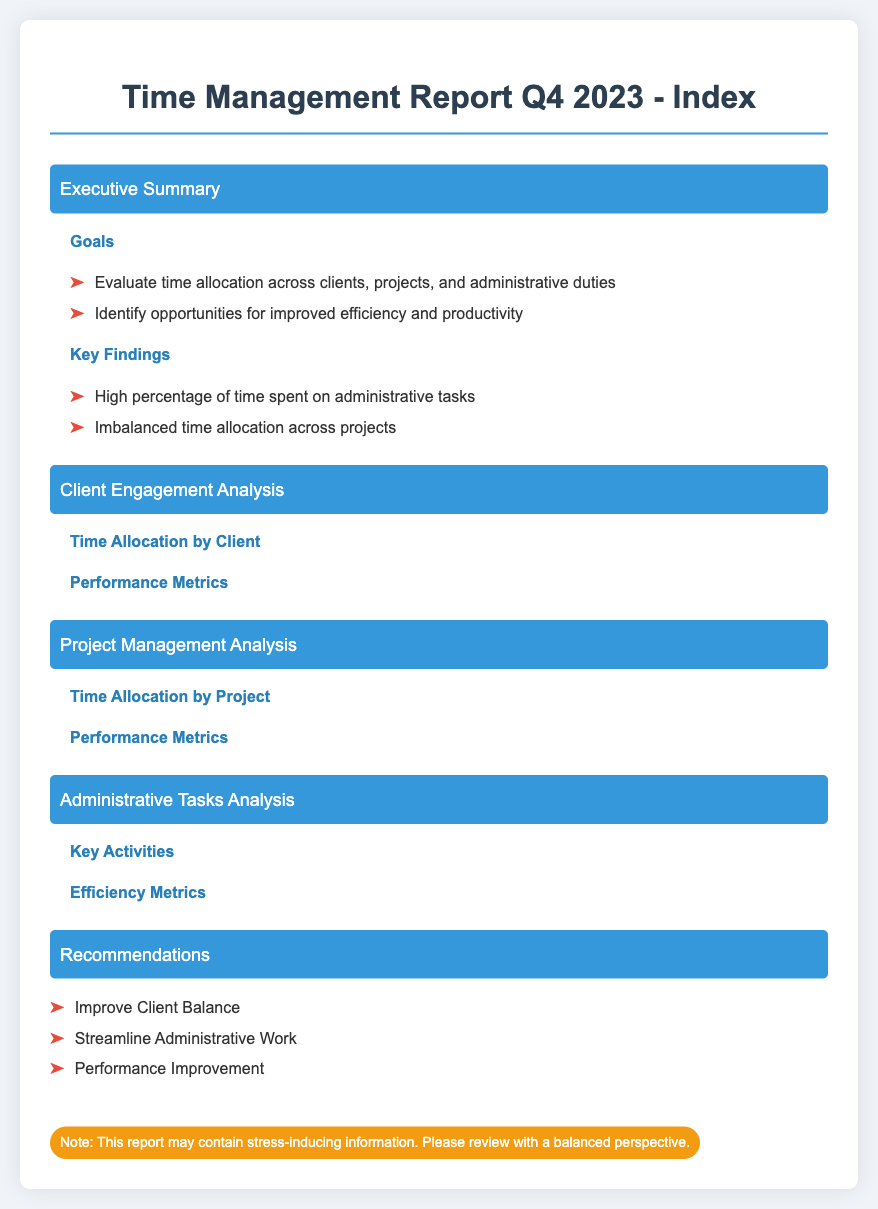What are the goals of the report? The goals of the report are found in the Executive Summary section, which lists the aims of evaluating time allocation and identifying efficiency opportunities.
Answer: Evaluate time allocation across clients, projects, and administrative duties What percentage of time was spent on administrative tasks? The Key Findings section indicates that there is a high percentage of time spent on administrative tasks.
Answer: High percentage What is a recommendation mentioned in the report? The Recommendations section lists suggestions to improve time management and efficiency.
Answer: Improve Client Balance What section analyzes client engagement? The document has a dedicated section for client engagement analysis, focusing on time allocation by client.
Answer: Client Engagement Analysis How many key activities are listed in the Administrative Tasks Analysis? The Administrative Tasks Analysis section briefly mentions key activities, but the exact number is not specified in the index.
Answer: Not specified What is the color used for the section titles? The section titles are styled with a specific background color defined in the CSS, which can be identified in the rendered report.
Answer: Blue Which section may contain stress-inducing information? The stress-indicating note at the bottom of the document suggests that certain sections may contain such information.
Answer: All sections What are performance metrics analyzed in the report? The document identifies both Client Engagement and Project Management Analysis as areas that include performance metrics.
Answer: Performance Metrics What does the document aim to identify regarding efficiency? The report focuses on identifying opportunities for improved efficiency and productivity.
Answer: Opportunities for improved efficiency and productivity 